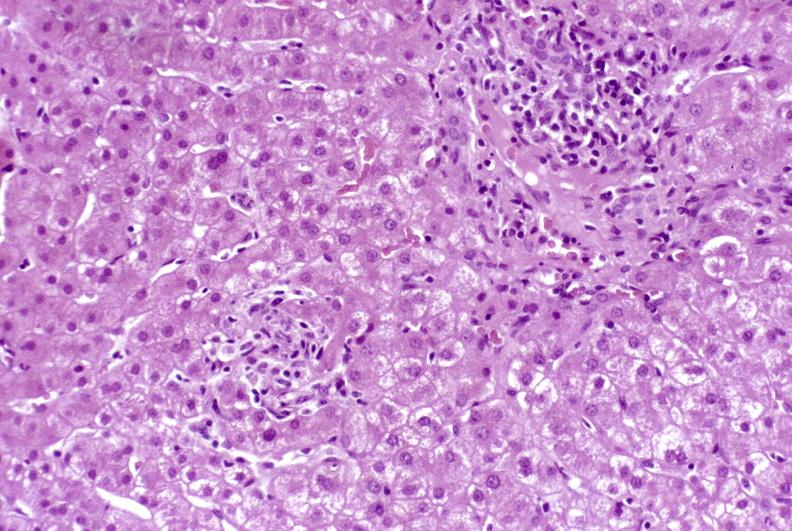s granulomata slide present?
Answer the question using a single word or phrase. No 